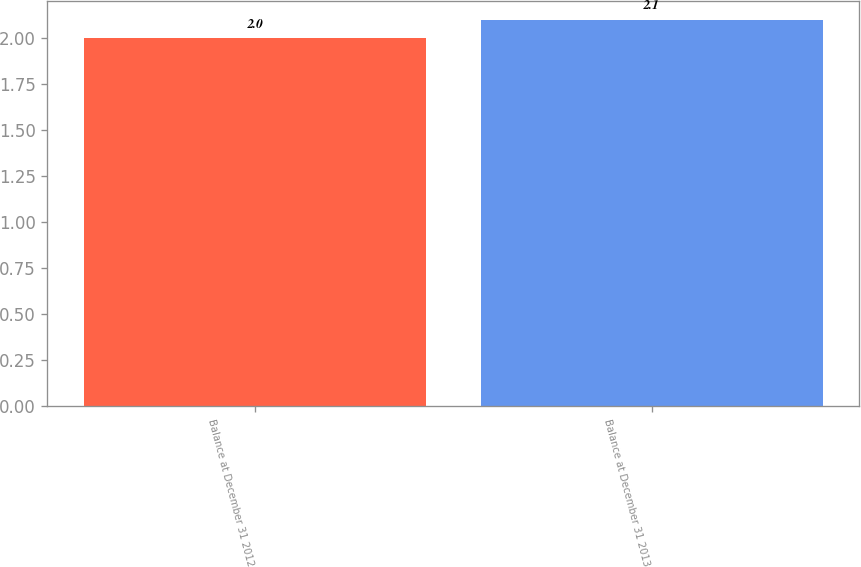Convert chart to OTSL. <chart><loc_0><loc_0><loc_500><loc_500><bar_chart><fcel>Balance at December 31 2012<fcel>Balance at December 31 2013<nl><fcel>2<fcel>2.1<nl></chart> 